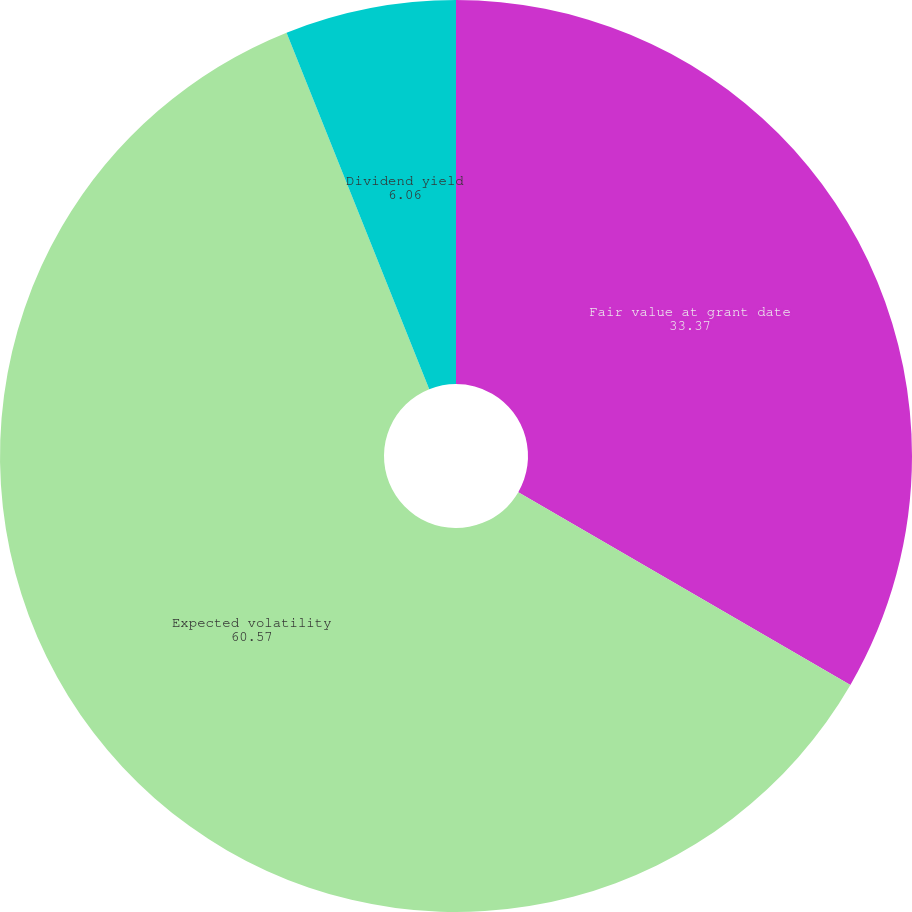Convert chart to OTSL. <chart><loc_0><loc_0><loc_500><loc_500><pie_chart><fcel>Fair value at grant date<fcel>Expected volatility<fcel>Dividend yield<nl><fcel>33.37%<fcel>60.57%<fcel>6.06%<nl></chart> 